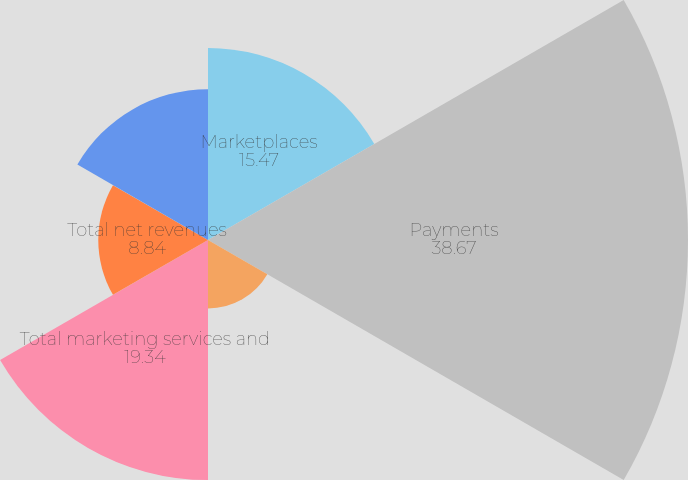<chart> <loc_0><loc_0><loc_500><loc_500><pie_chart><fcel>Marketplaces<fcel>Payments<fcel>Total net transaction revenues<fcel>Total marketing services and<fcel>Total net revenues<fcel>International<nl><fcel>15.47%<fcel>38.67%<fcel>5.52%<fcel>19.34%<fcel>8.84%<fcel>12.15%<nl></chart> 